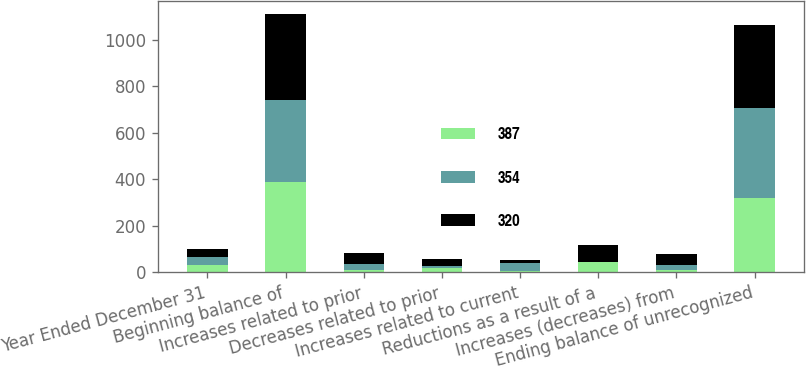<chart> <loc_0><loc_0><loc_500><loc_500><stacked_bar_chart><ecel><fcel>Year Ended December 31<fcel>Beginning balance of<fcel>Increases related to prior<fcel>Decreases related to prior<fcel>Increases related to current<fcel>Reductions as a result of a<fcel>Increases (decreases) from<fcel>Ending balance of unrecognized<nl><fcel>387<fcel>33<fcel>387<fcel>9<fcel>19<fcel>6<fcel>46<fcel>11<fcel>320<nl><fcel>354<fcel>33<fcel>354<fcel>26<fcel>10<fcel>33<fcel>1<fcel>21<fcel>387<nl><fcel>320<fcel>33<fcel>369<fcel>49<fcel>28<fcel>16<fcel>73<fcel>48<fcel>354<nl></chart> 